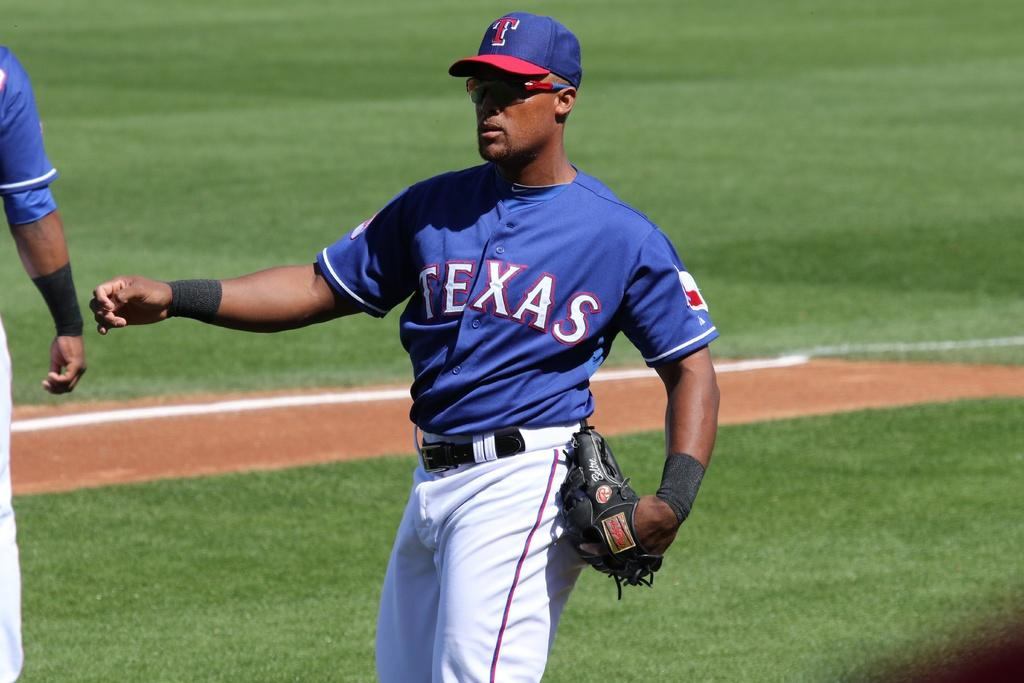Provide a one-sentence caption for the provided image. The blue uniform says the word Texas on the front of it. 